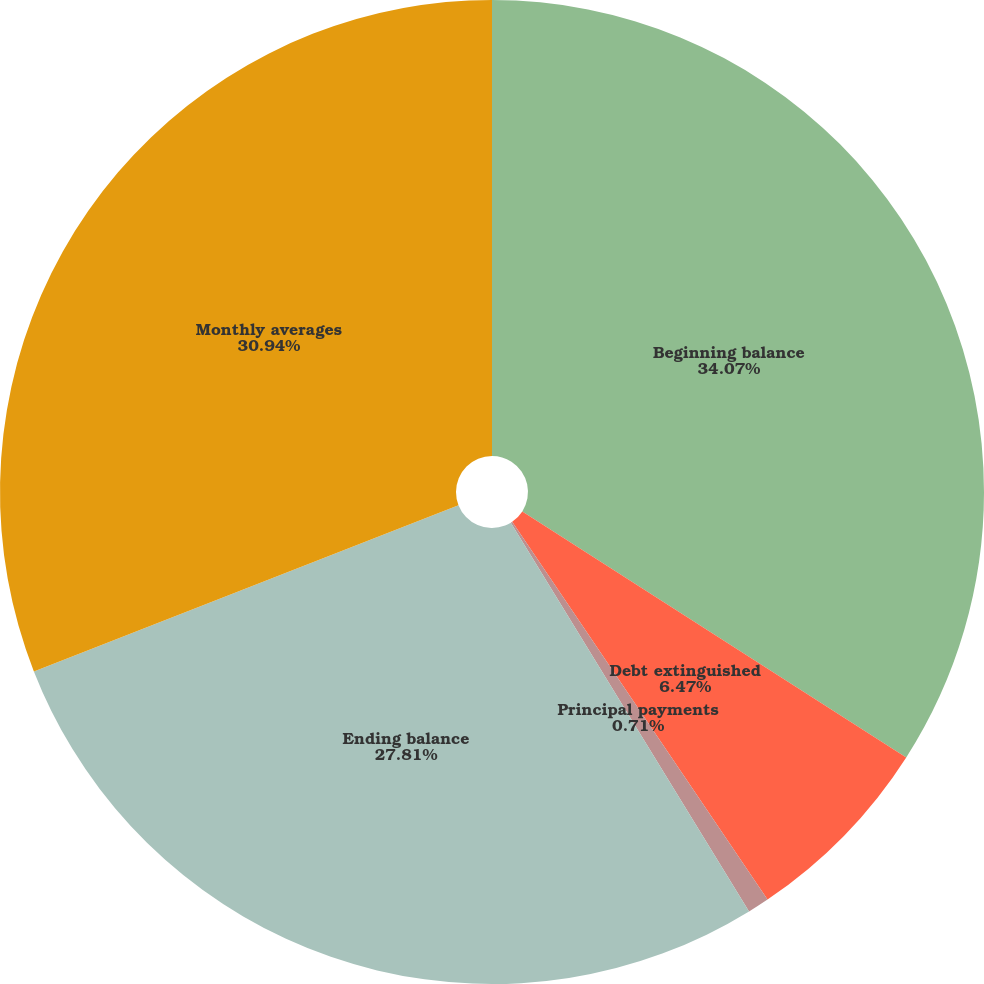Convert chart. <chart><loc_0><loc_0><loc_500><loc_500><pie_chart><fcel>Beginning balance<fcel>Debt extinguished<fcel>Principal payments<fcel>Ending balance<fcel>Monthly averages<nl><fcel>34.07%<fcel>6.47%<fcel>0.71%<fcel>27.81%<fcel>30.94%<nl></chart> 